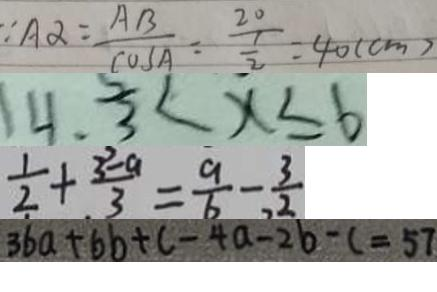<formula> <loc_0><loc_0><loc_500><loc_500>\because A \alpha = \frac { A B } { \cos A } = \frac { 2 0 } { \frac { 1 } { 2 } } = 4 0 ( c m ) 
 1 4 . 3 < x \leq 6 
 \frac { 1 } { 2 } + \frac { 3 - a } { 3 } = \frac { 9 } { 6 } - \frac { 3 } { 2 } 
 3 6 a + 6 b + c - 4 a - 2 b - c = 5 7</formula> 